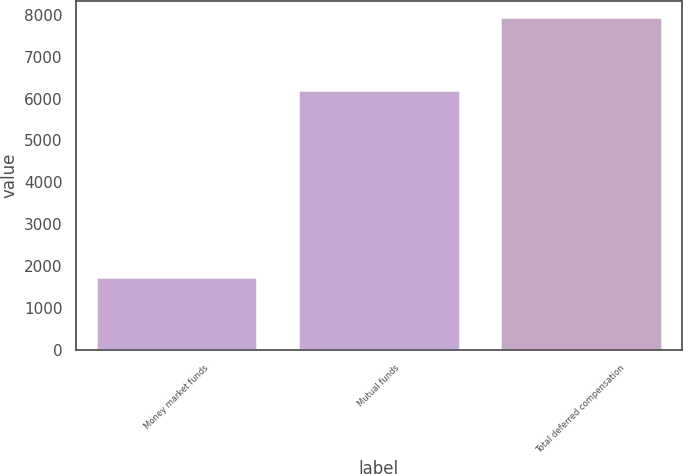Convert chart to OTSL. <chart><loc_0><loc_0><loc_500><loc_500><bar_chart><fcel>Money market funds<fcel>Mutual funds<fcel>Total deferred compensation<nl><fcel>1730<fcel>6213<fcel>7943<nl></chart> 